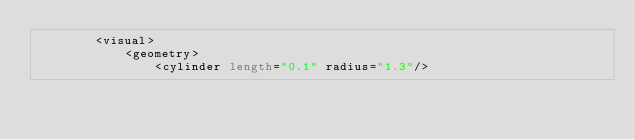Convert code to text. <code><loc_0><loc_0><loc_500><loc_500><_XML_>        <visual>
            <geometry>
                <cylinder length="0.1" radius="1.3"/></code> 